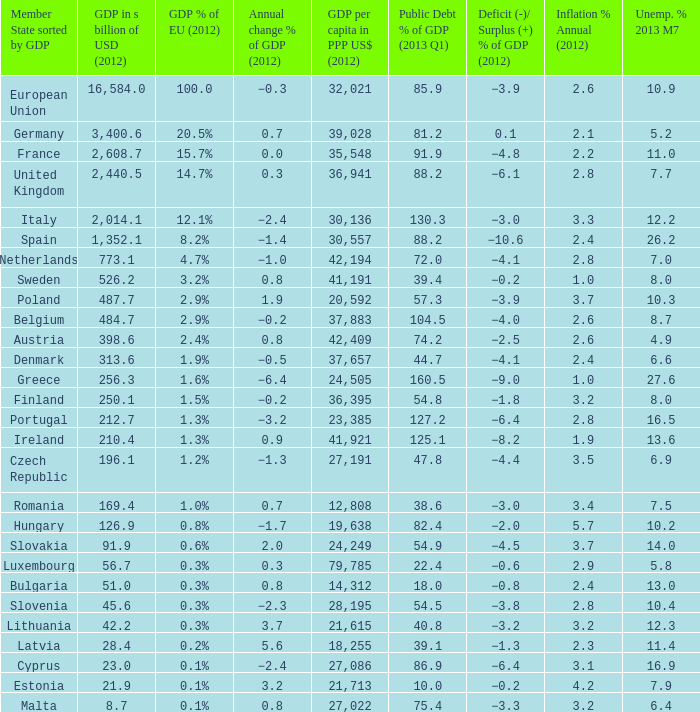9%? 2.6. 